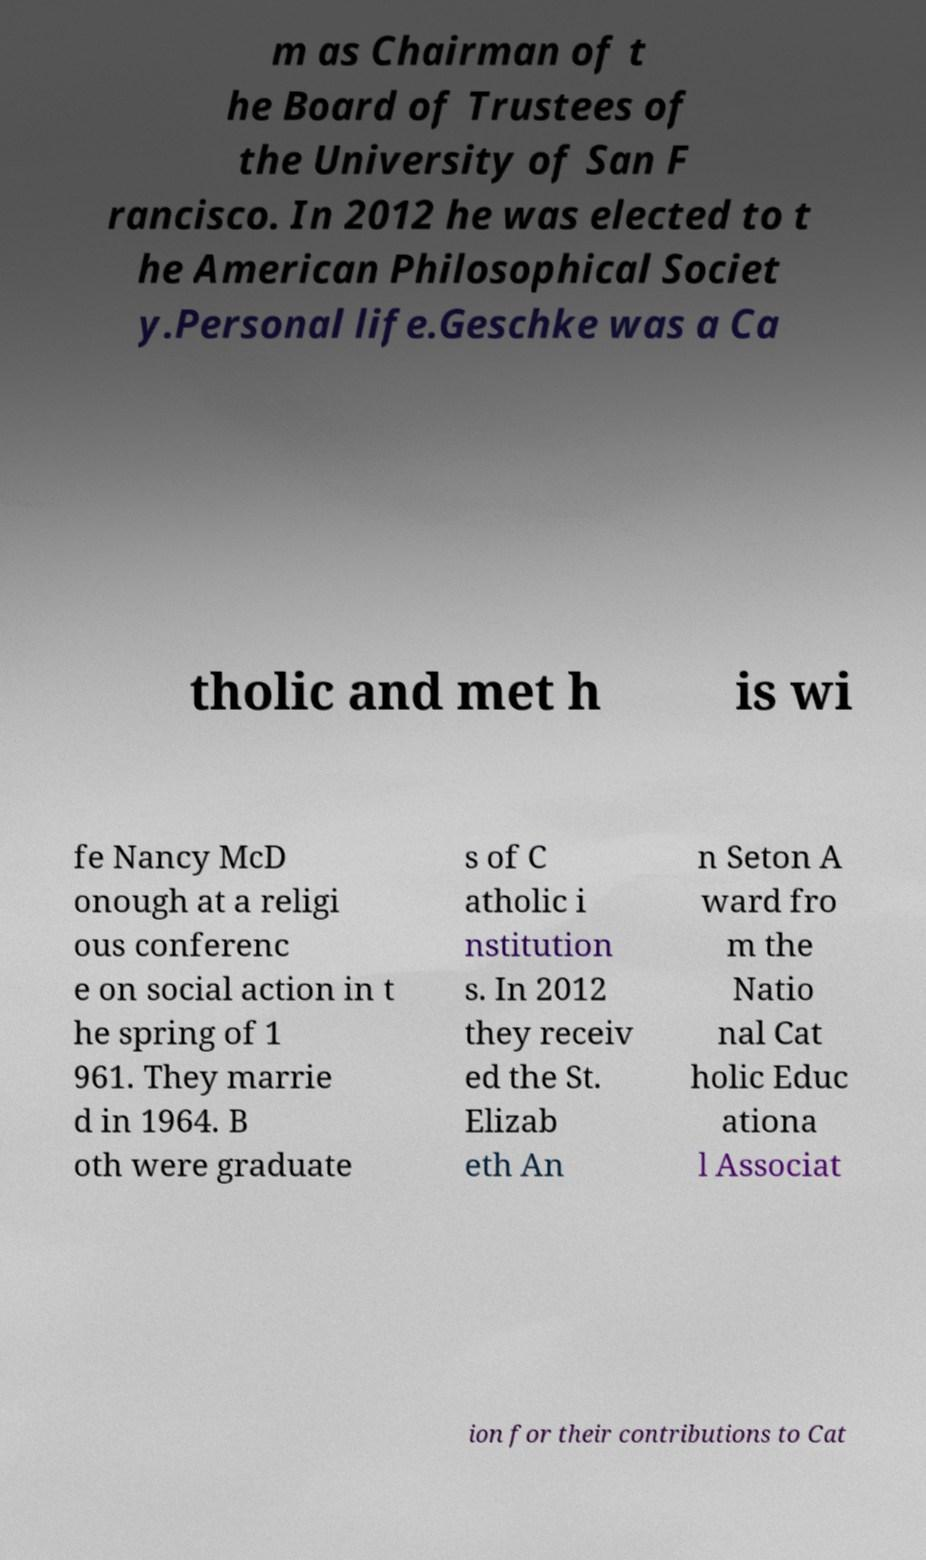Could you assist in decoding the text presented in this image and type it out clearly? m as Chairman of t he Board of Trustees of the University of San F rancisco. In 2012 he was elected to t he American Philosophical Societ y.Personal life.Geschke was a Ca tholic and met h is wi fe Nancy McD onough at a religi ous conferenc e on social action in t he spring of 1 961. They marrie d in 1964. B oth were graduate s of C atholic i nstitution s. In 2012 they receiv ed the St. Elizab eth An n Seton A ward fro m the Natio nal Cat holic Educ ationa l Associat ion for their contributions to Cat 